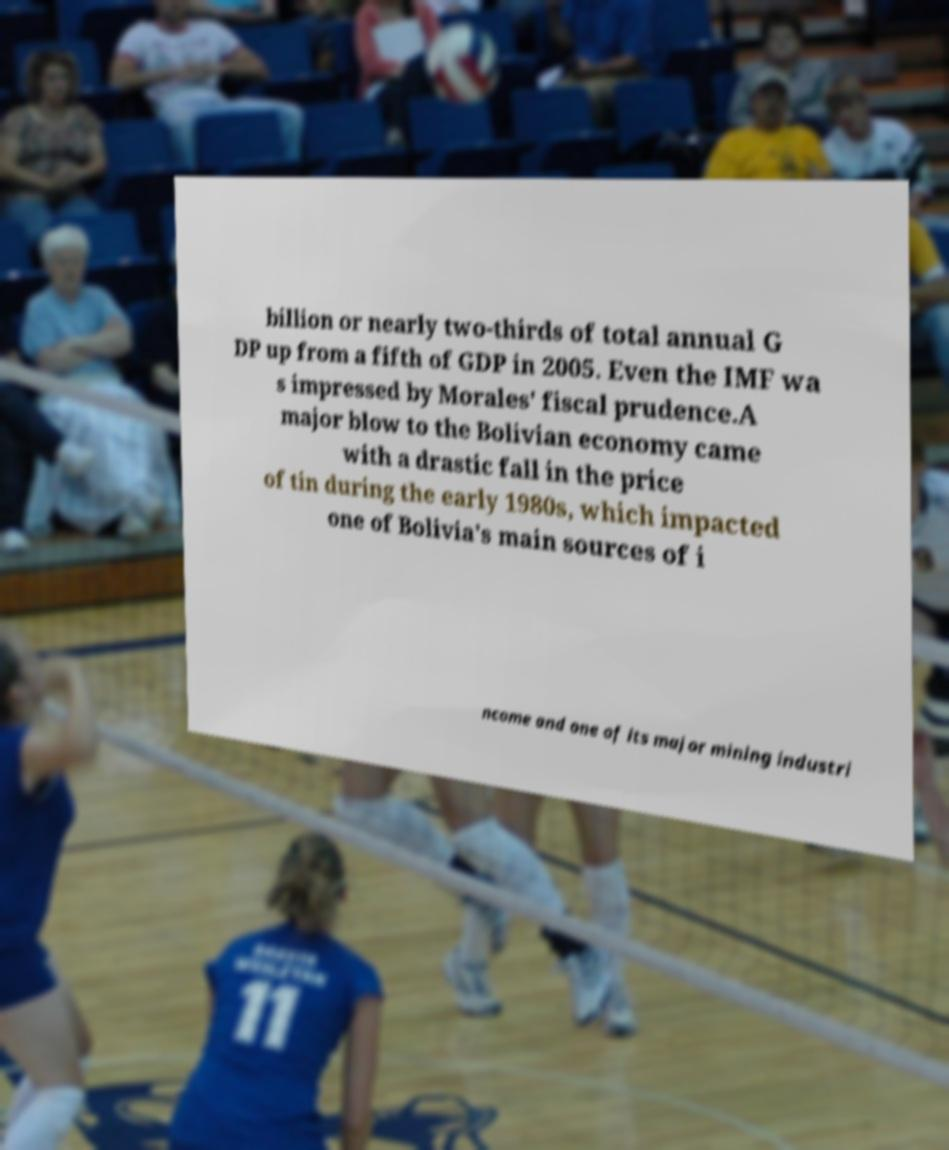Can you read and provide the text displayed in the image?This photo seems to have some interesting text. Can you extract and type it out for me? billion or nearly two-thirds of total annual G DP up from a fifth of GDP in 2005. Even the IMF wa s impressed by Morales' fiscal prudence.A major blow to the Bolivian economy came with a drastic fall in the price of tin during the early 1980s, which impacted one of Bolivia's main sources of i ncome and one of its major mining industri 